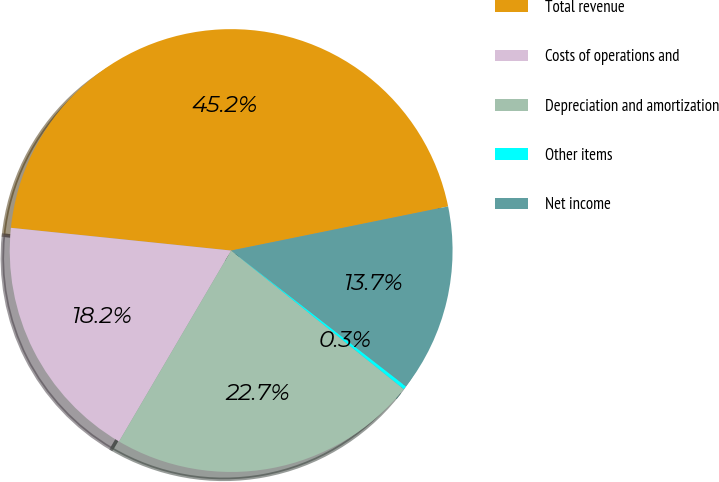Convert chart. <chart><loc_0><loc_0><loc_500><loc_500><pie_chart><fcel>Total revenue<fcel>Costs of operations and<fcel>Depreciation and amortization<fcel>Other items<fcel>Net income<nl><fcel>45.17%<fcel>18.19%<fcel>22.68%<fcel>0.26%<fcel>13.7%<nl></chart> 